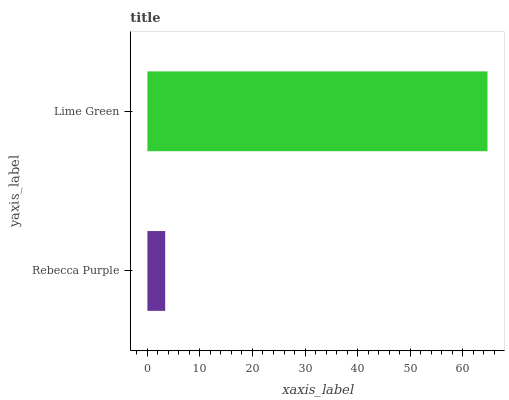Is Rebecca Purple the minimum?
Answer yes or no. Yes. Is Lime Green the maximum?
Answer yes or no. Yes. Is Lime Green the minimum?
Answer yes or no. No. Is Lime Green greater than Rebecca Purple?
Answer yes or no. Yes. Is Rebecca Purple less than Lime Green?
Answer yes or no. Yes. Is Rebecca Purple greater than Lime Green?
Answer yes or no. No. Is Lime Green less than Rebecca Purple?
Answer yes or no. No. Is Lime Green the high median?
Answer yes or no. Yes. Is Rebecca Purple the low median?
Answer yes or no. Yes. Is Rebecca Purple the high median?
Answer yes or no. No. Is Lime Green the low median?
Answer yes or no. No. 